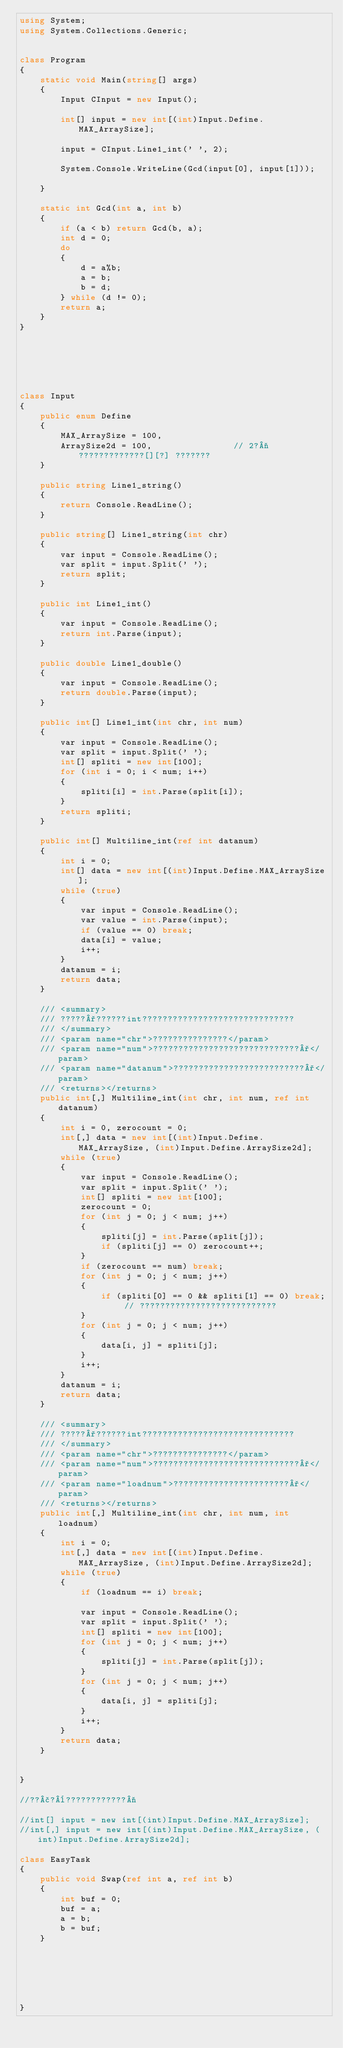<code> <loc_0><loc_0><loc_500><loc_500><_C#_>using System;
using System.Collections.Generic;


class Program
{
    static void Main(string[] args)
    {
        Input CInput = new Input();

        int[] input = new int[(int)Input.Define.MAX_ArraySize];

        input = CInput.Line1_int(' ', 2);

        System.Console.WriteLine(Gcd(input[0], input[1]));

    }

    static int Gcd(int a, int b)
    {
        if (a < b) return Gcd(b, a);
        int d = 0;
        do
        {
            d = a%b;
            a = b;
            b = d;
        } while (d != 0);
        return a;
    }
}






class Input
{
    public enum Define
    {
        MAX_ArraySize = 100,
        ArraySize2d = 100,                // 2?¬?????????????[][?] ???????
    }

    public string Line1_string()
    {
        return Console.ReadLine();
    }

    public string[] Line1_string(int chr)
    {
        var input = Console.ReadLine();
        var split = input.Split(' ');
        return split;
    }

    public int Line1_int()
    {
        var input = Console.ReadLine();
        return int.Parse(input);
    }

    public double Line1_double()
    {
        var input = Console.ReadLine();
        return double.Parse(input);
    }

    public int[] Line1_int(int chr, int num)
    {
        var input = Console.ReadLine();
        var split = input.Split(' ');
        int[] spliti = new int[100];
        for (int i = 0; i < num; i++)
        {
            spliti[i] = int.Parse(split[i]);
        }
        return spliti;
    }

    public int[] Multiline_int(ref int datanum)
    {
        int i = 0;
        int[] data = new int[(int)Input.Define.MAX_ArraySize];
        while (true)
        {
            var input = Console.ReadLine();
            var value = int.Parse(input);
            if (value == 0) break;
            data[i] = value;
            i++;
        }
        datanum = i;
        return data;
    }

    /// <summary>
    /// ?????°??????int??????????????????????????????
    /// </summary>
    /// <param name="chr">???????????????</param>
    /// <param name="num">?????????????????????????????°</param>
    /// <param name="datanum">??????????????????????????°</param>
    /// <returns></returns>
    public int[,] Multiline_int(int chr, int num, ref int datanum)
    {
        int i = 0, zerocount = 0;
        int[,] data = new int[(int)Input.Define.MAX_ArraySize, (int)Input.Define.ArraySize2d];
        while (true)
        {
            var input = Console.ReadLine();
            var split = input.Split(' ');
            int[] spliti = new int[100];
            zerocount = 0;
            for (int j = 0; j < num; j++)
            {
                spliti[j] = int.Parse(split[j]);
                if (spliti[j] == 0) zerocount++;
            }
            if (zerocount == num) break;
            for (int j = 0; j < num; j++)
            {
                if (spliti[0] == 0 && spliti[1] == 0) break; // ???????????????????????????
            }
            for (int j = 0; j < num; j++)
            {
                data[i, j] = spliti[j];
            }
            i++;
        }
        datanum = i;
        return data;
    }

    /// <summary>
    /// ?????°??????int??????????????????????????????
    /// </summary>
    /// <param name="chr">???????????????</param>
    /// <param name="num">?????????????????????????????°</param>
    /// <param name="loadnum">???????????????????????°</param>
    /// <returns></returns>
    public int[,] Multiline_int(int chr, int num, int loadnum)
    {
        int i = 0;
        int[,] data = new int[(int)Input.Define.MAX_ArraySize, (int)Input.Define.ArraySize2d];
        while (true)
        {
            if (loadnum == i) break;

            var input = Console.ReadLine();
            var split = input.Split(' ');
            int[] spliti = new int[100];
            for (int j = 0; j < num; j++)
            {
                spliti[j] = int.Parse(split[j]);
            }
            for (int j = 0; j < num; j++)
            {
                data[i, j] = spliti[j];
            }
            i++;
        }
        return data;
    }


}

//??£?¨????????????¬

//int[] input = new int[(int)Input.Define.MAX_ArraySize];
//int[,] input = new int[(int)Input.Define.MAX_ArraySize, (int)Input.Define.ArraySize2d];

class EasyTask
{
    public void Swap(ref int a, ref int b)
    {
        int buf = 0;
        buf = a;
        a = b;
        b = buf;
    }






}</code> 